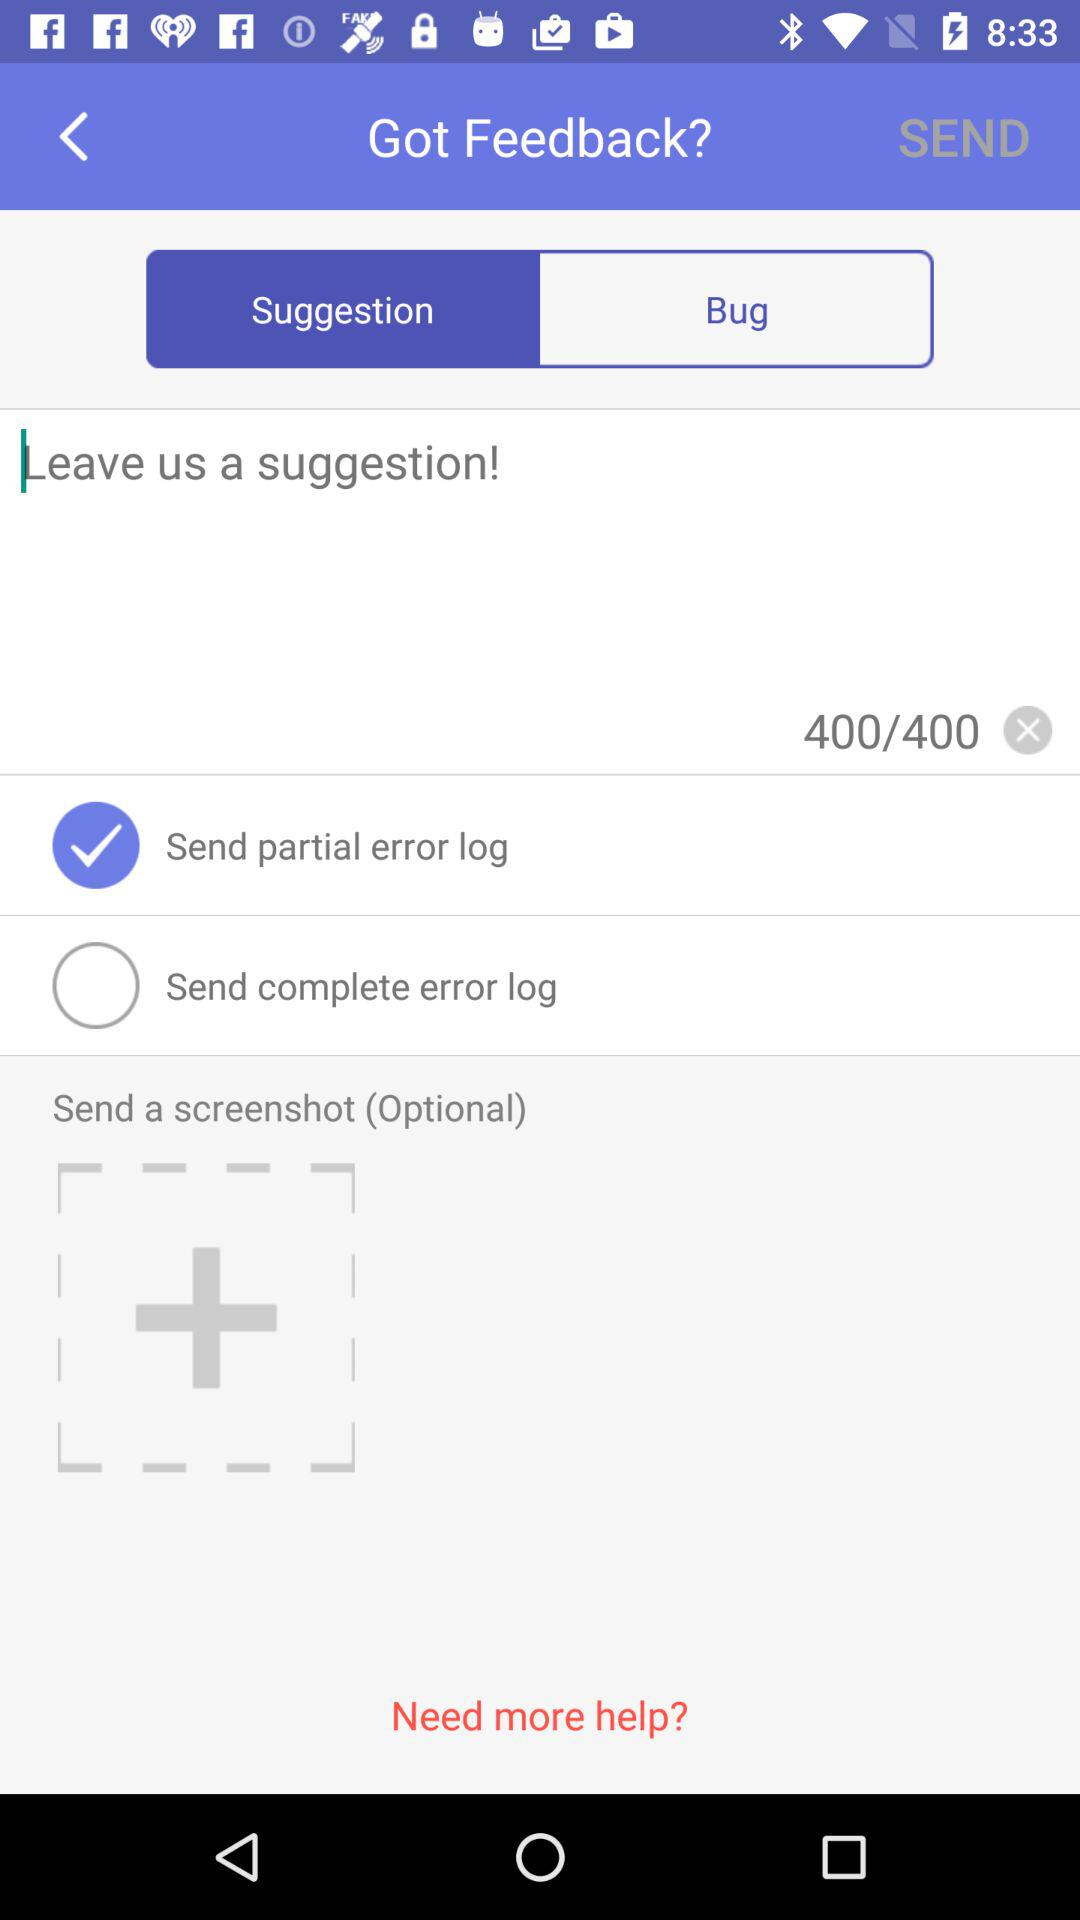What is the maximum number of characters I can write in a suggestion? The maximum number of characters I can write in a suggestion is 400. 